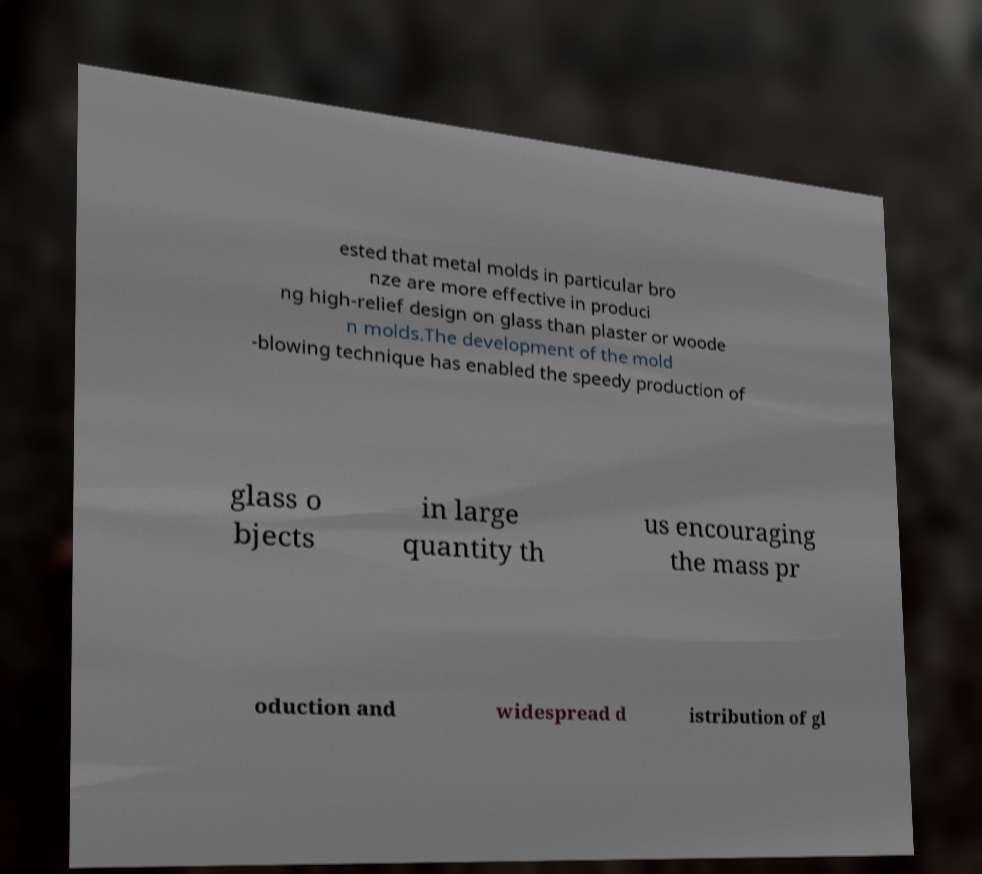I need the written content from this picture converted into text. Can you do that? ested that metal molds in particular bro nze are more effective in produci ng high-relief design on glass than plaster or woode n molds.The development of the mold -blowing technique has enabled the speedy production of glass o bjects in large quantity th us encouraging the mass pr oduction and widespread d istribution of gl 